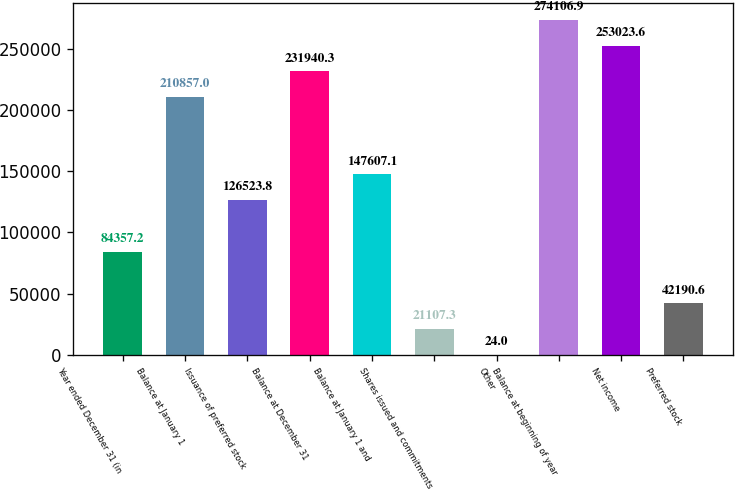Convert chart. <chart><loc_0><loc_0><loc_500><loc_500><bar_chart><fcel>Year ended December 31 (in<fcel>Balance at January 1<fcel>Issuance of preferred stock<fcel>Balance at December 31<fcel>Balance at January 1 and<fcel>Shares issued and commitments<fcel>Other<fcel>Balance at beginning of year<fcel>Net income<fcel>Preferred stock<nl><fcel>84357.2<fcel>210857<fcel>126524<fcel>231940<fcel>147607<fcel>21107.3<fcel>24<fcel>274107<fcel>253024<fcel>42190.6<nl></chart> 